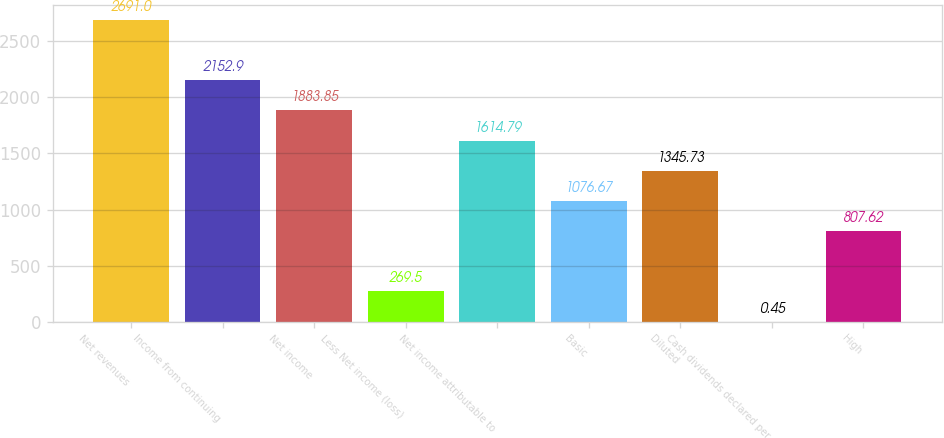<chart> <loc_0><loc_0><loc_500><loc_500><bar_chart><fcel>Net revenues<fcel>Income from continuing<fcel>Net income<fcel>Less Net income (loss)<fcel>Net income attributable to<fcel>Basic<fcel>Diluted<fcel>Cash dividends declared per<fcel>High<nl><fcel>2691<fcel>2152.9<fcel>1883.85<fcel>269.5<fcel>1614.79<fcel>1076.67<fcel>1345.73<fcel>0.45<fcel>807.62<nl></chart> 